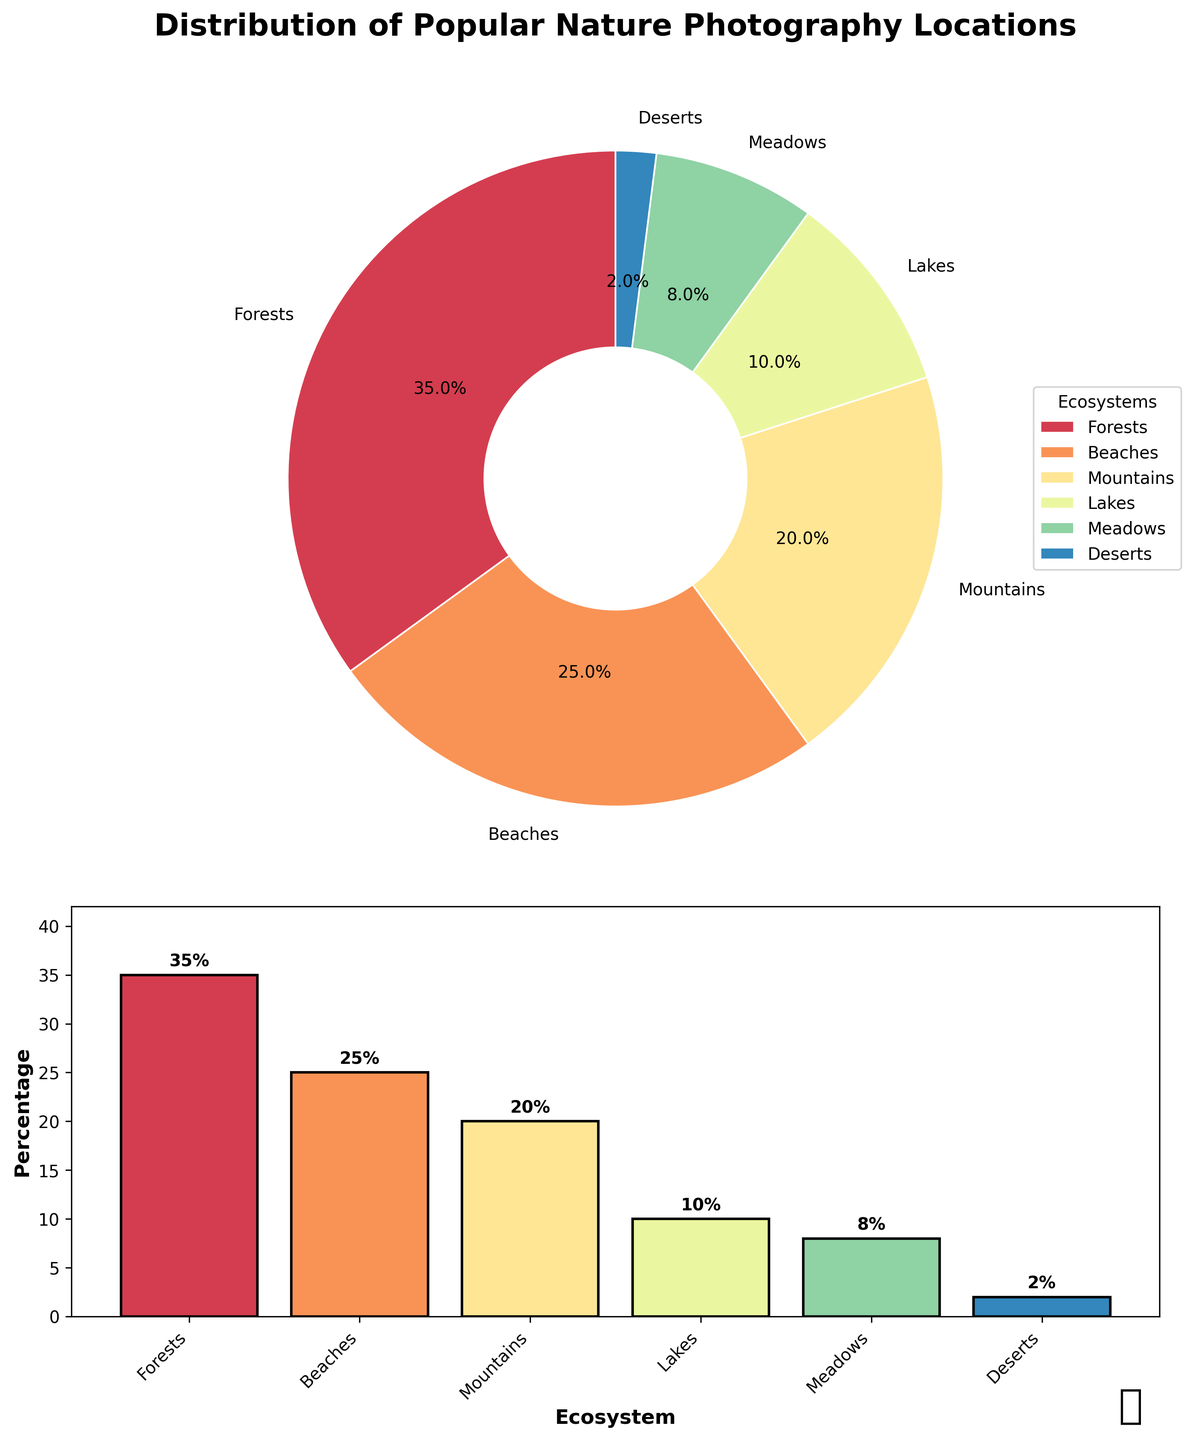Which ecosystem type has the highest percentage of popular nature photography locations? The pie chart and bar chart both clearly indicate that forests have the highest percentage of locations.
Answer: Forests Which two ecosystems combined cover half of the popular nature photography locations? Adding up the percentages of the two largest segments in the pie chart, forests (35%) and beaches (25%), equals 60%, which is more than half. The next highest combining with forests would be beaches, giving 60%.
Answer: Forests and beaches How much more popular are forests than lakes for nature photography locations? Forests are 35% and lakes are 10%, so the difference is 35% - 10% = 25%.
Answer: 25% Which two ecosystems are each less popular than 10% for nature photography locations? Observing the bar chart, deserts (2%) and meadows (8%) both fall under 10%.
Answer: Deserts and meadows Which ecosystem type constitutes twice the percentage of lakes? The percentage for lakes is 10%. Analyzing the bar chart, mountains at 20% are exactly twice the percentage of lakes.
Answer: Mountains Describe the range of percentages covered by all the ecosystem types. The pie and bar charts show the lowest percentage is 2% (deserts) and the highest is 35% (forests), therefore the range is 35% - 2%.
Answer: 33% What is the total percentage of locations in ecosystems that are less than 20% each? Summing up the bar chart values below 20% includes lakes (10%), meadows (8%), and deserts (2%) for a total of 10% + 8% + 2% = 20%.
Answer: 20% Compare the popularity of meadows and deserts. How many times more popular are meadows? The bar chart shows meadows at 8% and deserts at 2%. To find how many times more popular meadows are, divide 8% by 2%: 8 / 2 = 4 times more popular.
Answer: 4 times How do the percentages of mountains and lakes compare? From the bar chart, mountains are 20% and lakes are 10%. Mountains are double the percentage of lakes.
Answer: Mountains are double What visual element indicates the title of the figure? The title is prominently displayed above the pie chart, stating "Distribution of Popular Nature Photography Locations."
Answer: Distribution of Popular Nature Photography Locations 